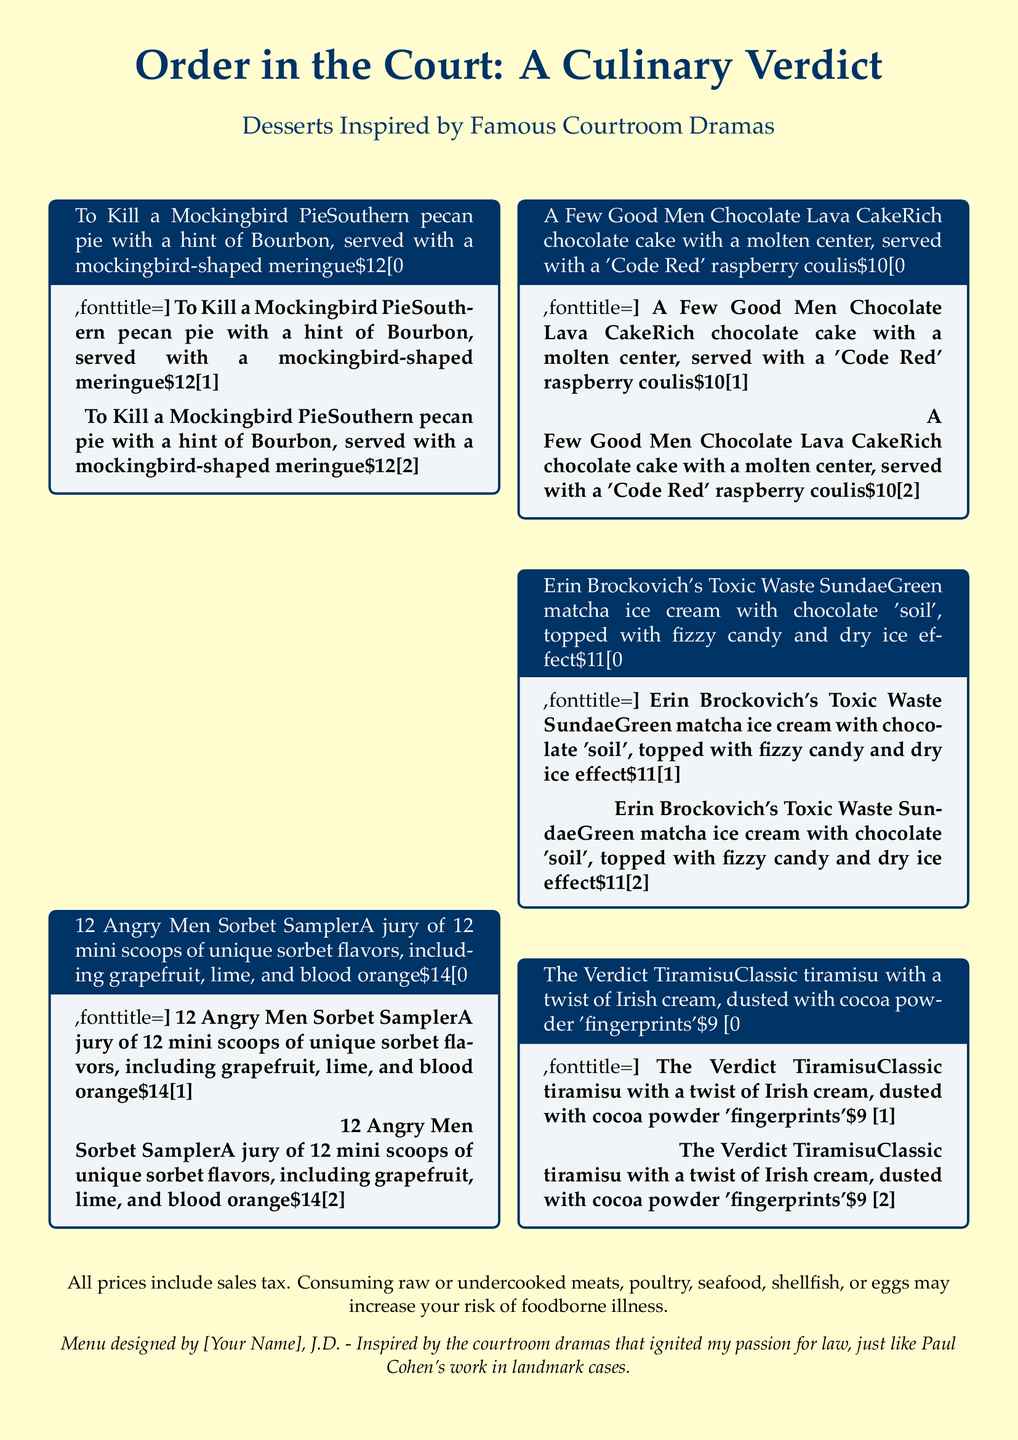What is the title of the dessert menu? The title is prominently displayed at the top of the menu, which is "Order in the Court: A Culinary Verdict."
Answer: Order in the Court: A Culinary Verdict How many desserts are listed on the menu? The menu features a total of five unique dessert items inspired by courtroom dramas.
Answer: Five What is the price of the Tiramisu dessert? The price for "The Verdict Tiramisu" is stated on the menu alongside its description.
Answer: $9 Which dessert includes green matcha ice cream? The menu specifically describes "Erin Brockovich's Toxic Waste Sundae" as containing green matcha ice cream.
Answer: Erin Brockovich's Toxic Waste Sundae What is unique about the "12 Angry Men Sorbet Sampler"? The dessert is presented as a sampler with twelve mini scoops of different flavors, which is a notable detail.
Answer: A jury of 12 mini scoops Which dessert has a molten center? The dessert described as having a molten center is "A Few Good Men Chocolate Lava Cake."
Answer: A Few Good Men Chocolate Lava Cake What drink pairing could complement these legal-themed desserts? This question invites reasoning by requiring connection between the theme and potential drink options, such as coffee or sweet tea, but is not directly answered in the document.
Answer: Not answered in document What is offered alongside the pecan pie? The description of "To Kill a Mockingbird Pie" mentions a specific side presentation that adds to its appeal.
Answer: Mockingbird-shaped meringue How is "Erin Brockovich's Toxic Waste Sundae" visually served? The dessert is highlighted with a unique presentation effect described in its details, creating a visual spectacle.
Answer: Dry ice effect 